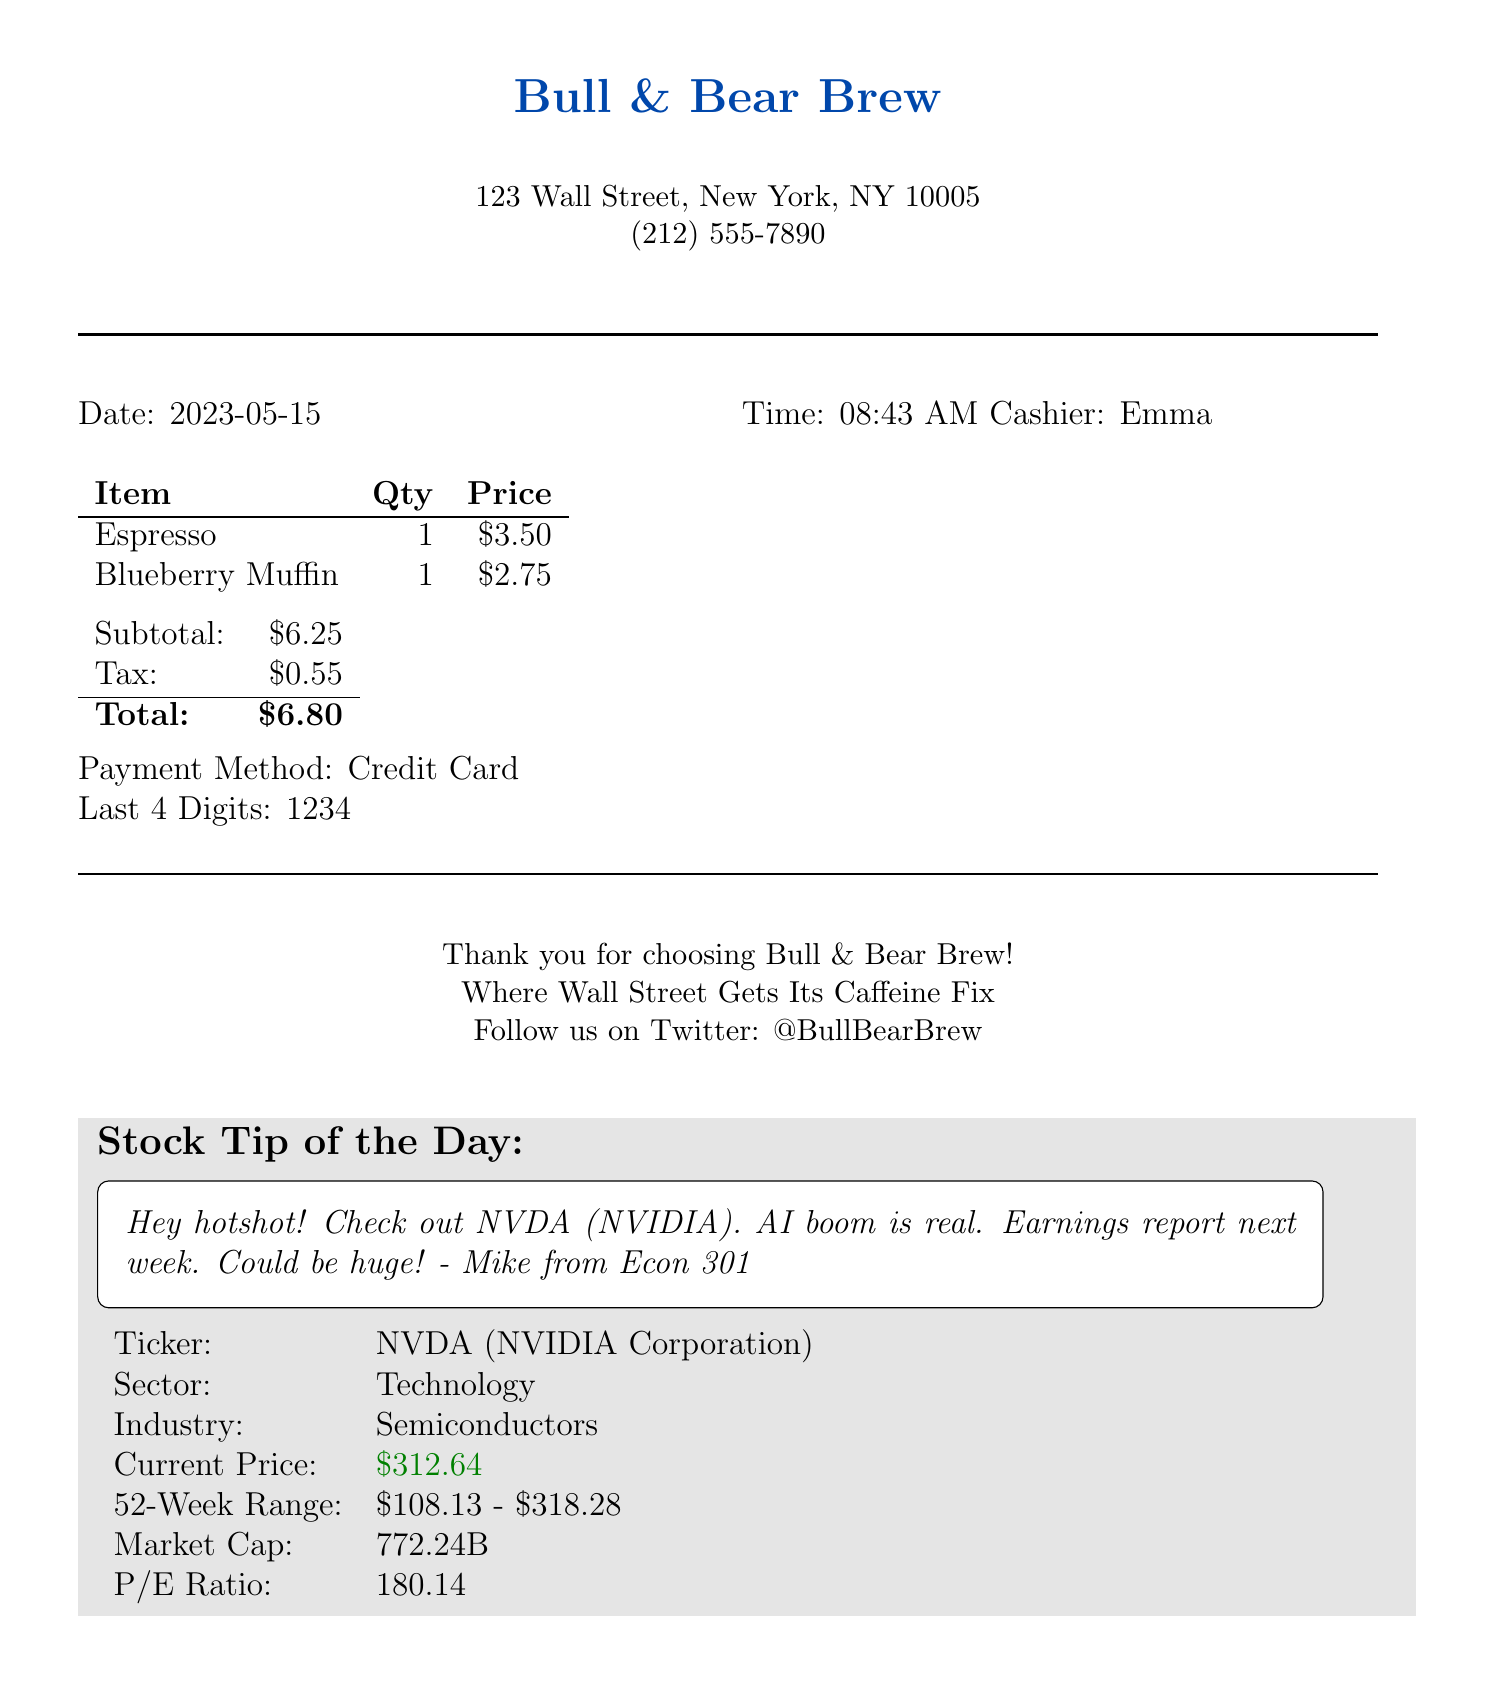What is the name of the coffee shop? The name of the coffee shop is presented at the top of the receipt.
Answer: Bull & Bear Brew What item had a price of $3.50? The price of each item is listed in the order items section of the receipt.
Answer: Espresso What is the total amount on the receipt? The total amount is calculated from the subtotal plus tax, shown at the bottom of the receipt.
Answer: $6.80 Who was the cashier? The cashier's name is mentioned in the receipt.
Answer: Emma What is the ticker symbol mentioned in the handwritten note? The stock tip section includes the ticker symbol for the company.
Answer: NVDA What is the current price of NVIDIA Corporation? The current price is specified in the stock tip details section of the document.
Answer: $312.64 Which industry does NVIDIA Corporation belong to? The industry is part of the stock tip details that categorize the company.
Answer: Semiconductors What is the date of the purchase? The date is clearly indicated in the receipt.
Answer: 2023-05-15 What is the 52-week high price for NVIDIA? The 52-week high price is provided in the stock tip section for market analysis.
Answer: $318.28 